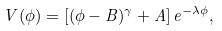Convert formula to latex. <formula><loc_0><loc_0><loc_500><loc_500>V ( \phi ) = [ ( \phi - B ) ^ { \gamma } + A ] \, e ^ { - \lambda \phi } ,</formula> 